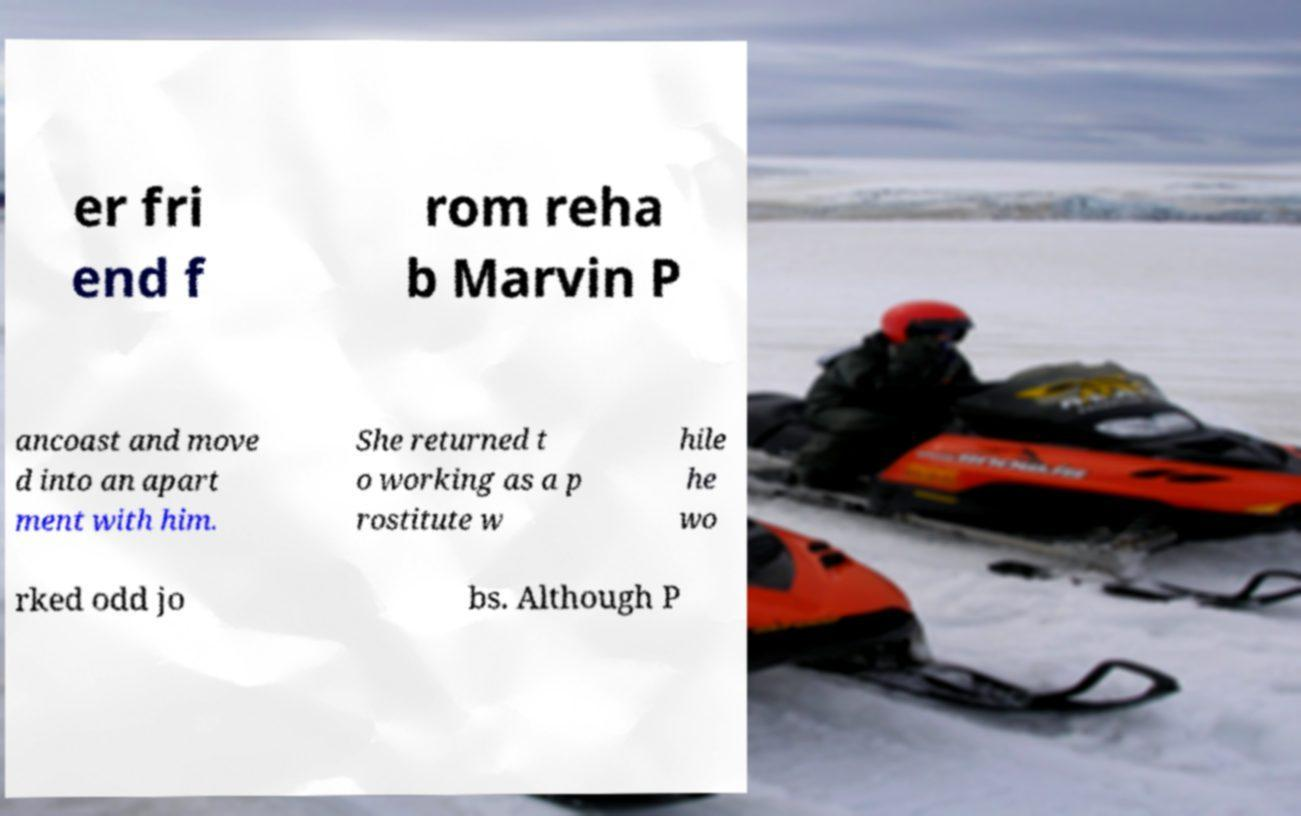Can you accurately transcribe the text from the provided image for me? er fri end f rom reha b Marvin P ancoast and move d into an apart ment with him. She returned t o working as a p rostitute w hile he wo rked odd jo bs. Although P 